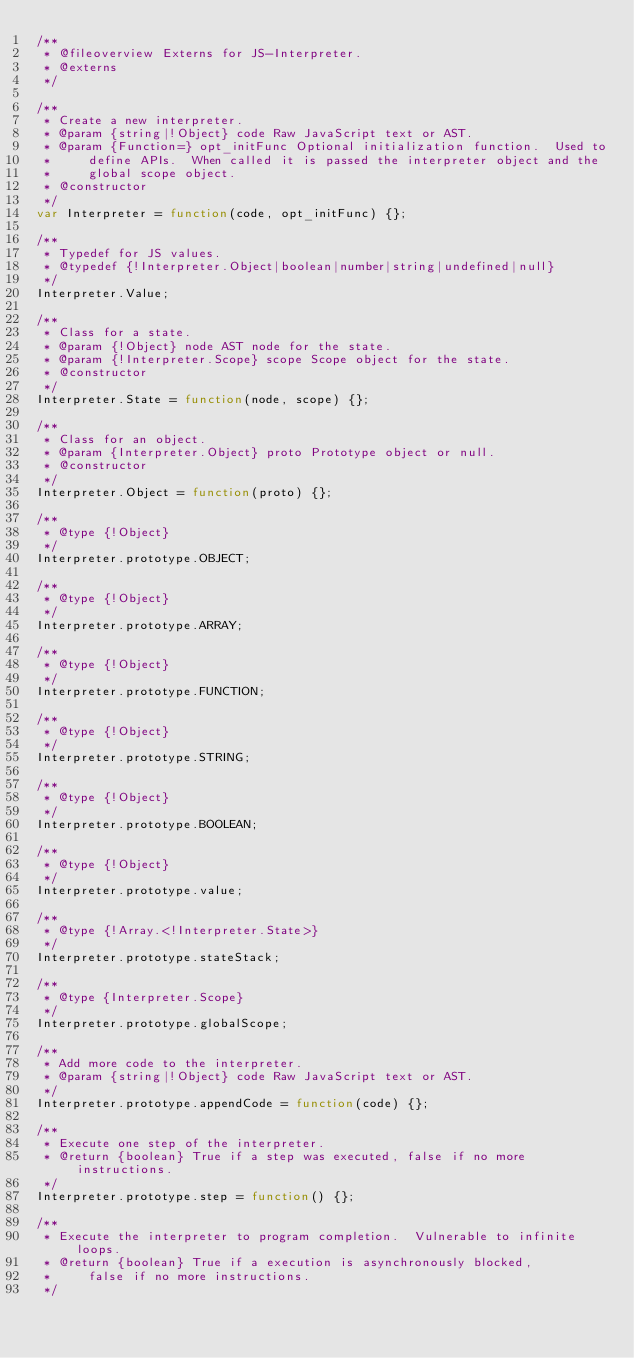Convert code to text. <code><loc_0><loc_0><loc_500><loc_500><_JavaScript_>/**
 * @fileoverview Externs for JS-Interpreter.
 * @externs
 */

/**
 * Create a new interpreter.
 * @param {string|!Object} code Raw JavaScript text or AST.
 * @param {Function=} opt_initFunc Optional initialization function.  Used to
 *     define APIs.  When called it is passed the interpreter object and the
 *     global scope object.
 * @constructor
 */
var Interpreter = function(code, opt_initFunc) {};

/**
 * Typedef for JS values.
 * @typedef {!Interpreter.Object|boolean|number|string|undefined|null}
 */
Interpreter.Value;

/**
 * Class for a state.
 * @param {!Object} node AST node for the state.
 * @param {!Interpreter.Scope} scope Scope object for the state.
 * @constructor
 */
Interpreter.State = function(node, scope) {};

/**
 * Class for an object.
 * @param {Interpreter.Object} proto Prototype object or null.
 * @constructor
 */
Interpreter.Object = function(proto) {};

/**
 * @type {!Object}
 */
Interpreter.prototype.OBJECT;

/**
 * @type {!Object}
 */
Interpreter.prototype.ARRAY;

/**
 * @type {!Object}
 */
Interpreter.prototype.FUNCTION;

/**
 * @type {!Object}
 */
Interpreter.prototype.STRING;

/**
 * @type {!Object}
 */
Interpreter.prototype.BOOLEAN;

/**
 * @type {!Object}
 */
Interpreter.prototype.value;

/**
 * @type {!Array.<!Interpreter.State>}
 */
Interpreter.prototype.stateStack;

/**
 * @type {Interpreter.Scope}
 */
Interpreter.prototype.globalScope;

/**
 * Add more code to the interpreter.
 * @param {string|!Object} code Raw JavaScript text or AST.
 */
Interpreter.prototype.appendCode = function(code) {};

/**
 * Execute one step of the interpreter.
 * @return {boolean} True if a step was executed, false if no more instructions.
 */
Interpreter.prototype.step = function() {};

/**
 * Execute the interpreter to program completion.  Vulnerable to infinite loops.
 * @return {boolean} True if a execution is asynchronously blocked,
 *     false if no more instructions.
 */</code> 